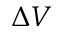Convert formula to latex. <formula><loc_0><loc_0><loc_500><loc_500>\Delta V</formula> 